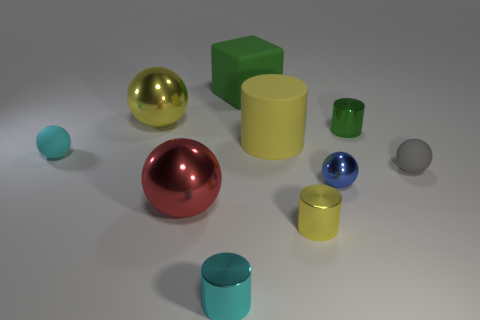Subtract 1 cylinders. How many cylinders are left? 3 Subtract all small gray matte spheres. How many spheres are left? 4 Subtract all blue spheres. How many spheres are left? 4 Subtract all brown cylinders. Subtract all red spheres. How many cylinders are left? 4 Subtract all cylinders. How many objects are left? 6 Subtract all big purple blocks. Subtract all green matte blocks. How many objects are left? 9 Add 5 cyan matte spheres. How many cyan matte spheres are left? 6 Add 7 brown matte balls. How many brown matte balls exist? 7 Subtract 1 yellow spheres. How many objects are left? 9 